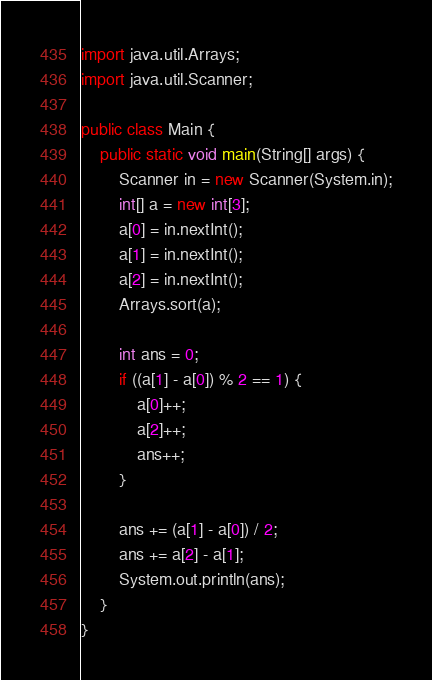Convert code to text. <code><loc_0><loc_0><loc_500><loc_500><_Java_>import java.util.Arrays;
import java.util.Scanner;

public class Main {
    public static void main(String[] args) {
        Scanner in = new Scanner(System.in);
        int[] a = new int[3];
        a[0] = in.nextInt();
        a[1] = in.nextInt();
        a[2] = in.nextInt();
        Arrays.sort(a);

        int ans = 0;
        if ((a[1] - a[0]) % 2 == 1) {
            a[0]++;
            a[2]++;
            ans++;
        }

        ans += (a[1] - a[0]) / 2;
        ans += a[2] - a[1];
        System.out.println(ans);
    }
}</code> 